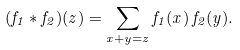<formula> <loc_0><loc_0><loc_500><loc_500>( f _ { 1 } * f _ { 2 } ) ( z ) = \sum _ { x + y = z } f _ { 1 } ( x ) \, f _ { 2 } ( y ) .</formula> 